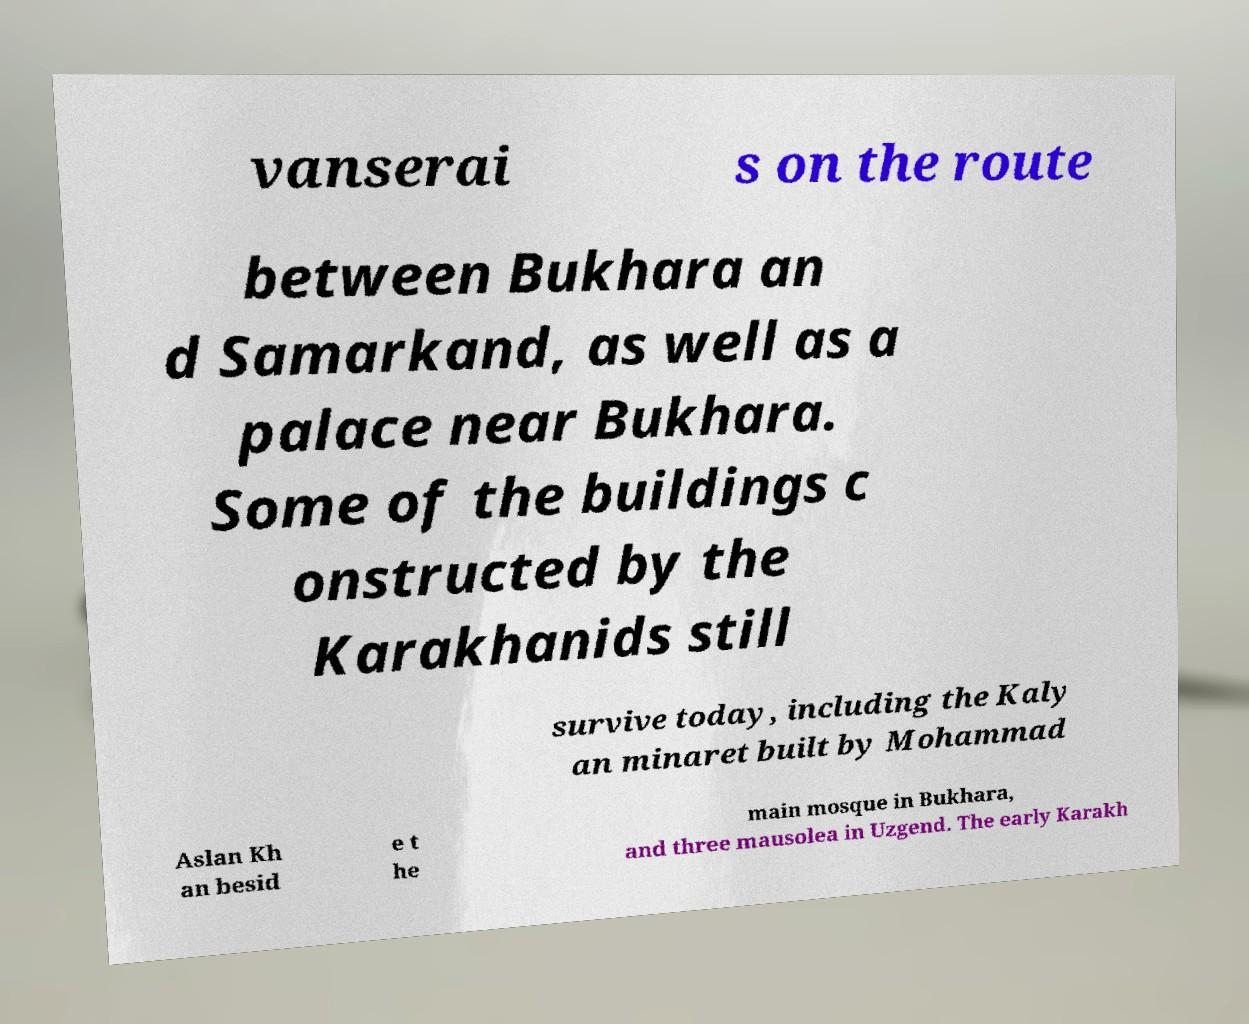There's text embedded in this image that I need extracted. Can you transcribe it verbatim? vanserai s on the route between Bukhara an d Samarkand, as well as a palace near Bukhara. Some of the buildings c onstructed by the Karakhanids still survive today, including the Kaly an minaret built by Mohammad Aslan Kh an besid e t he main mosque in Bukhara, and three mausolea in Uzgend. The early Karakh 